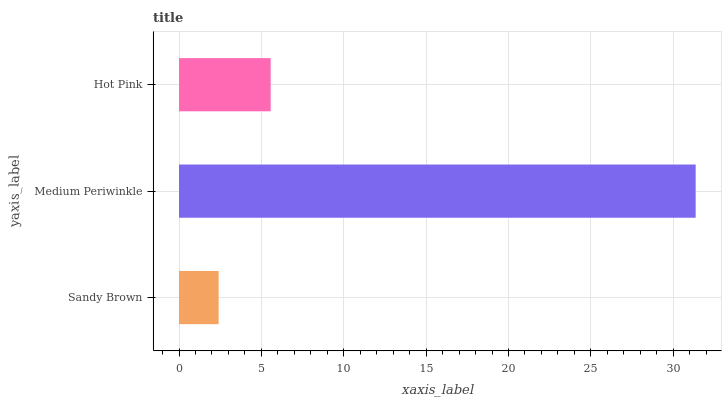Is Sandy Brown the minimum?
Answer yes or no. Yes. Is Medium Periwinkle the maximum?
Answer yes or no. Yes. Is Hot Pink the minimum?
Answer yes or no. No. Is Hot Pink the maximum?
Answer yes or no. No. Is Medium Periwinkle greater than Hot Pink?
Answer yes or no. Yes. Is Hot Pink less than Medium Periwinkle?
Answer yes or no. Yes. Is Hot Pink greater than Medium Periwinkle?
Answer yes or no. No. Is Medium Periwinkle less than Hot Pink?
Answer yes or no. No. Is Hot Pink the high median?
Answer yes or no. Yes. Is Hot Pink the low median?
Answer yes or no. Yes. Is Medium Periwinkle the high median?
Answer yes or no. No. Is Medium Periwinkle the low median?
Answer yes or no. No. 